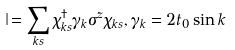<formula> <loc_0><loc_0><loc_500><loc_500>\jmath & = \sum _ { k s } \chi ^ { \dagger } _ { k s } \gamma _ { k } \sigma ^ { z } \chi _ { k s } , \gamma _ { k } = 2 t _ { 0 } \sin k</formula> 